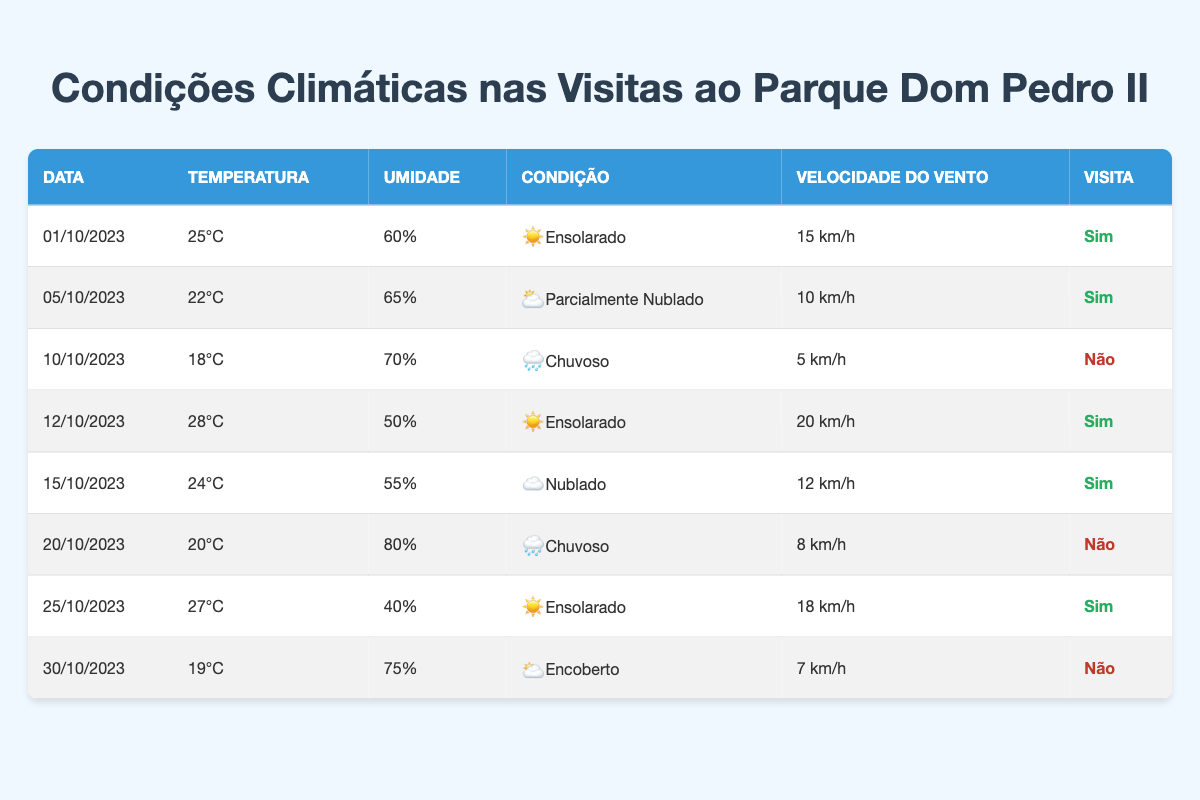What date had the highest temperature during a visit? The highest temperature recorded during a visit is 28°C on 12/10/2023. By examining the "Temperature" column for rows marked "Sim" (yes for visit), we find that the maximum temperature is on this date.
Answer: 12/10/2023 How many visits were made on cloudy or overcast days? The visits were made on 15/10/2023 (Cloudy) and none on the 30/10/2023 (Overcast). Therefore, there were two instances to consider, but only one day (the 15th) resulted in a visit marked "Sim" (yes).
Answer: 1 Was there any visit on a rainy day? Looking at the data, the visits on rainy days (10/10/2023 and 20/10/2023) are marked as "Não" (no), meaning no visits occurred on those days. Thus, the answer is no visits on rainy days.
Answer: No What is the average humidity of the days when visits were made? The days with visits occurred on 01/10 (60%), 05/10 (65%), 12/10 (50%), 15/10 (55%), and 25/10 (40%). To find the average humidity, sum these percentages: 60 + 65 + 50 + 55 + 40 = 270, then divide by 5 (number of visits), resulting in an average of 54%.
Answer: 54% How many total visits were made in October 2023? After reviewing the data, the visits occurred on 01/10, 05/10, 12/10, 15/10, and 25/10, which adds up to 5 days where visits were marked "Sim" (yes). So, the total number of visits is 5.
Answer: 5 On which date was the lowest wind speed recorded during a visit? From analyzing the "WindSpeed" column for the visited days (01/10, 05/10, 12/10, 15/10, and 25/10), the lowest recorded wind speed is 10 km/h on 05/10/2023. Thus, the answer is this specific date.
Answer: 05/10/2023 Which weather condition was most common on visit days? The data shows that out of the five visit days, there were three days with "Sunny" conditions (01/10, 12/10, and 25/10) and one day each for "Partly Cloudy" (05/10) and "Cloudy" (15/10). Thus, "Sunny" was the most common weather condition for visits.
Answer: Sunny What percentage of the days in October had a visit? There are a total of 8 days considered in October 2023 data, with 5 marked as visits ("Sim"). To calculate the percentage, we use (5 visits / 8 total days) * 100, which results in 62.5%. Thus, rounding gives an approximate of 63%.
Answer: 63% 